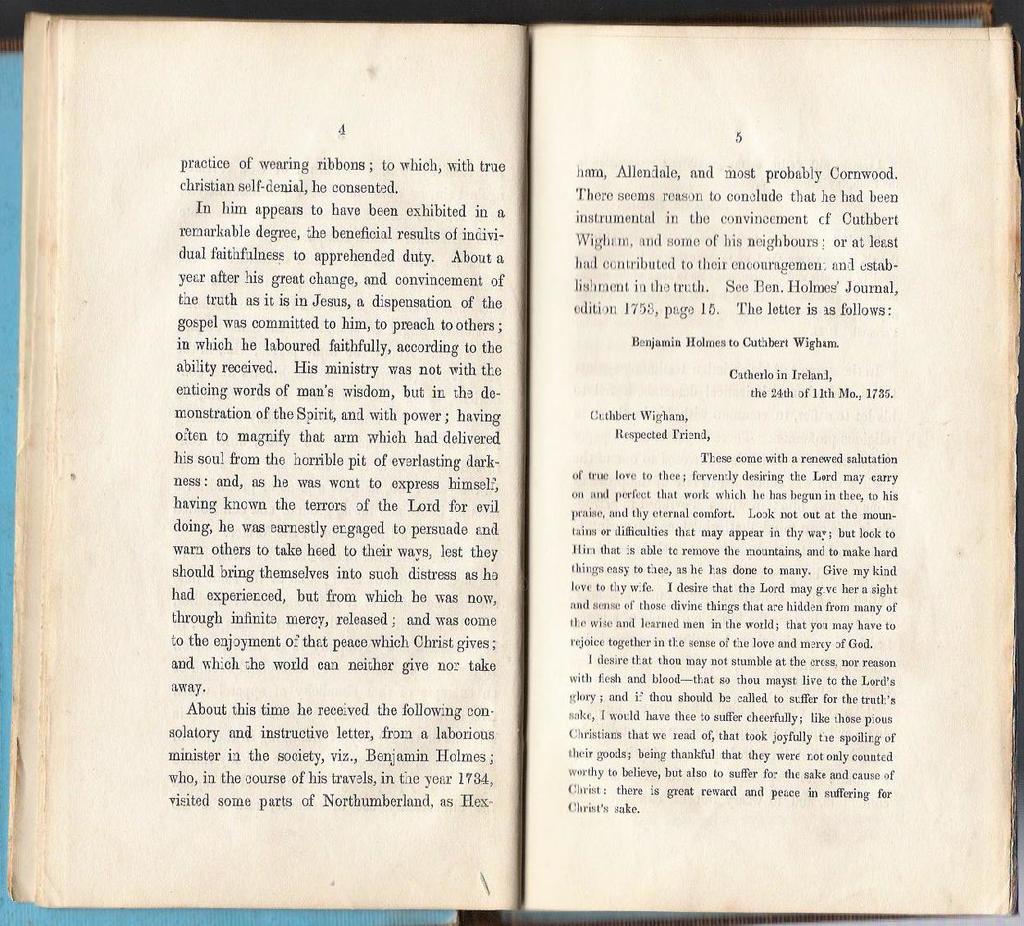What pages is the book flipped to?
Provide a short and direct response. 4 and 5. 